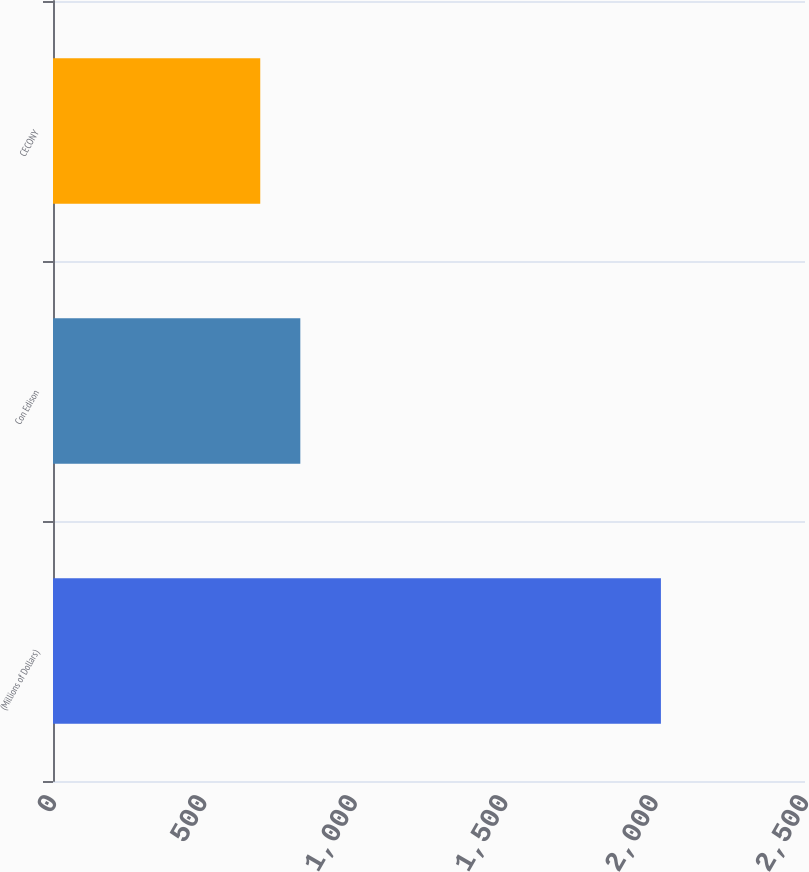Convert chart to OTSL. <chart><loc_0><loc_0><loc_500><loc_500><bar_chart><fcel>(Millions of Dollars)<fcel>Con Edison<fcel>CECONY<nl><fcel>2021<fcel>822.2<fcel>689<nl></chart> 